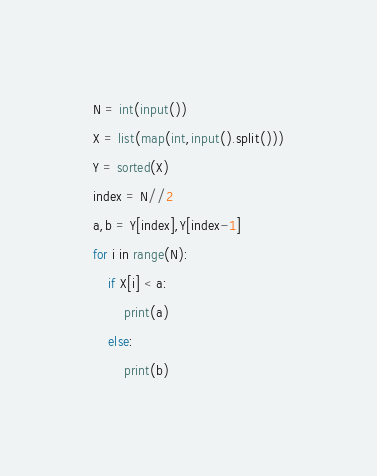Convert code to text. <code><loc_0><loc_0><loc_500><loc_500><_Python_>N = int(input())
X = list(map(int,input().split()))
Y = sorted(X)
index = N//2
a,b = Y[index],Y[index-1]
for i in range(N):
    if X[i] < a:
        print(a)
    else:
        print(b)</code> 